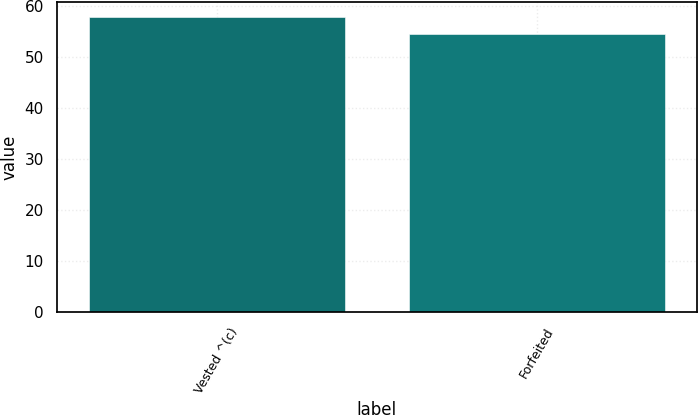Convert chart. <chart><loc_0><loc_0><loc_500><loc_500><bar_chart><fcel>Vested ^(c)<fcel>Forfeited<nl><fcel>57.87<fcel>54.46<nl></chart> 